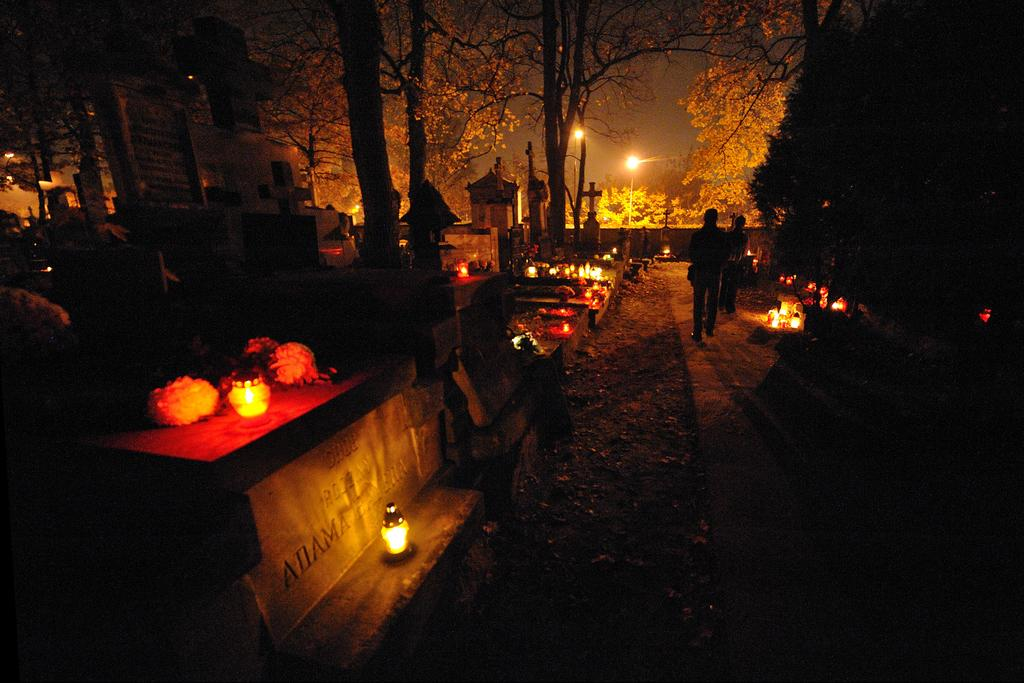What is the main setting of the image? The image depicts a graveyard. Are there any noticeable features on the left side of the graveyard? Yes, there are lights on the left side of the graveyard. What is the person in the image doing? A person is walking in the middle of the image. What type of vegetation can be seen in the image? There are trees in the image. What type of statement is written on the mailbox in the image? There is no mail or statement present in the image; it depicts a graveyard with a person walking and trees. How many fingers can be seen on the person's hand in the image? The image does not show the person's hand or fingers; it only shows the person walking. 